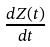Convert formula to latex. <formula><loc_0><loc_0><loc_500><loc_500>\frac { d Z ( t ) } { d t }</formula> 